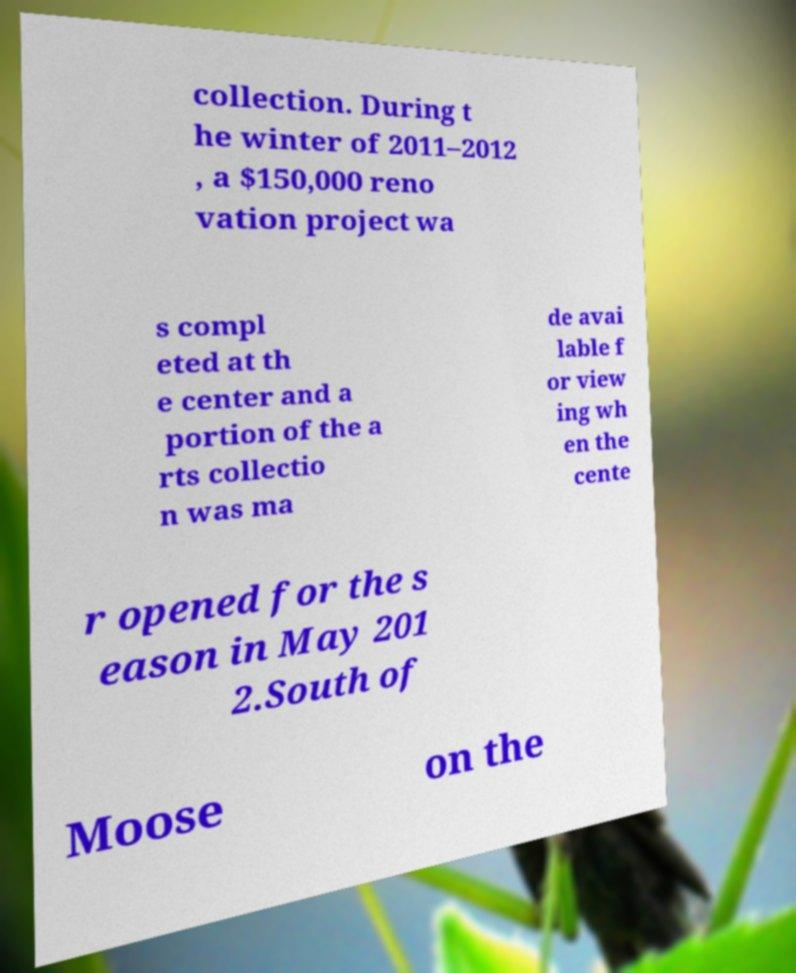For documentation purposes, I need the text within this image transcribed. Could you provide that? collection. During t he winter of 2011–2012 , a $150,000 reno vation project wa s compl eted at th e center and a portion of the a rts collectio n was ma de avai lable f or view ing wh en the cente r opened for the s eason in May 201 2.South of Moose on the 